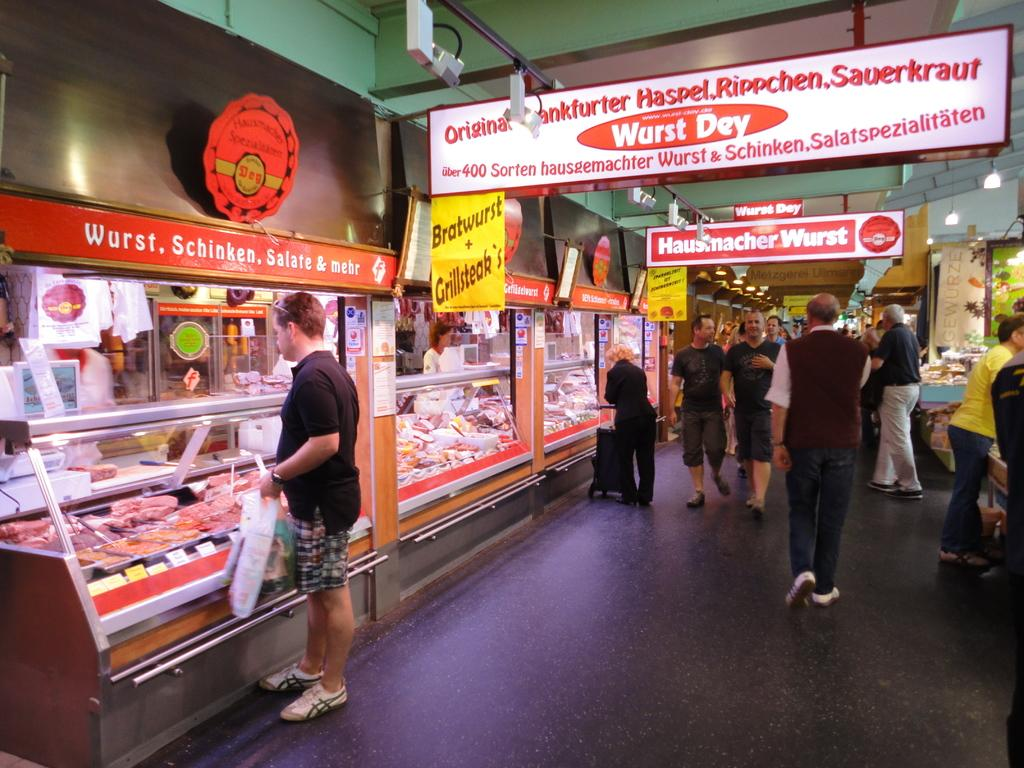Provide a one-sentence caption for the provided image. A group of customers stroll passed a Wurst Dey meat shop. 